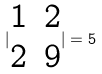<formula> <loc_0><loc_0><loc_500><loc_500>| \begin{matrix} 1 & 2 \\ 2 & 9 \\ \end{matrix} | = 5</formula> 